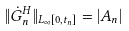Convert formula to latex. <formula><loc_0><loc_0><loc_500><loc_500>\| \dot { G } _ { n } ^ { H } \| _ { L _ { \infty } [ 0 , t _ { n } ] } = | A _ { n } |</formula> 